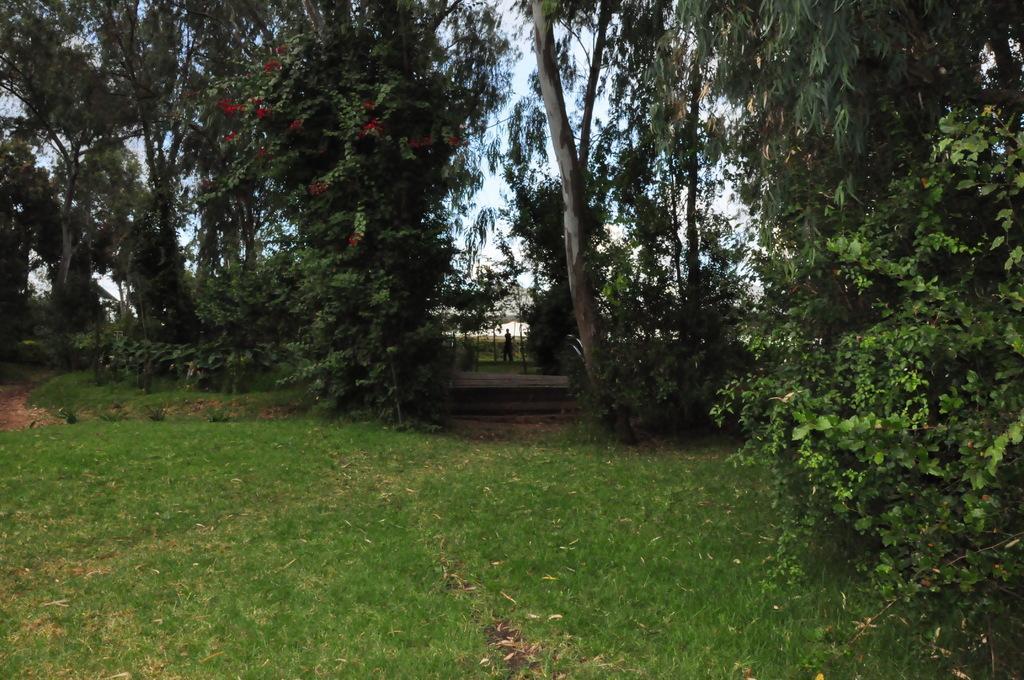Describe this image in one or two sentences. In this image we can see grassy land, plants and trees. Behind the trees, we can see the sky. There is a person in the middle of the image. 